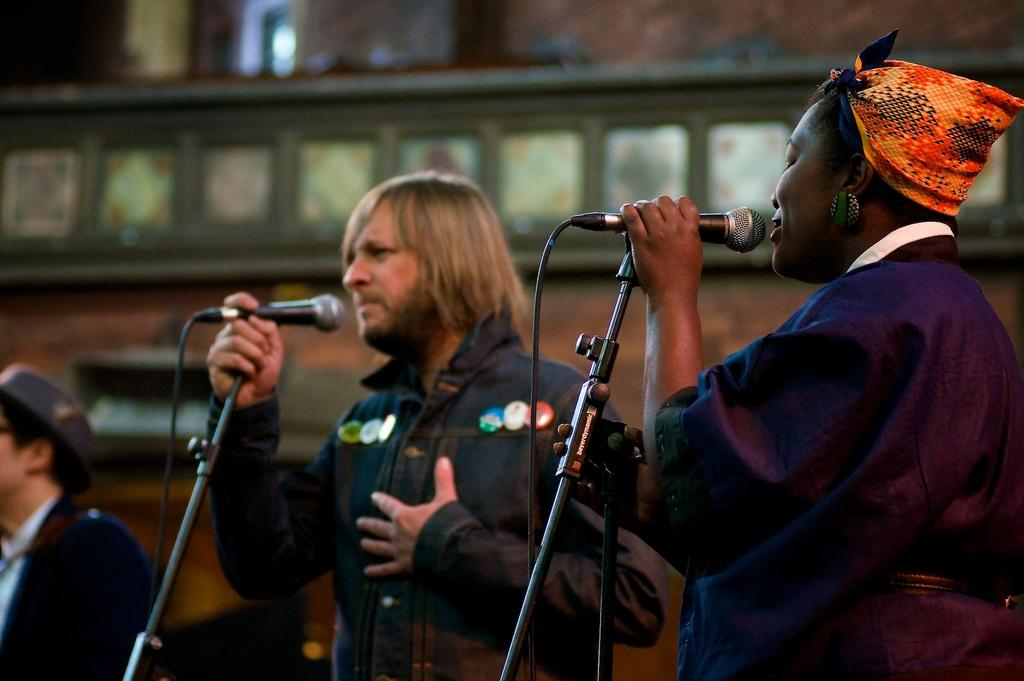What is the man in the image doing? The man is standing and singing in the image. What is the man holding in his hand? The man is holding a microphone in his hand. What is the woman in the image doing? The woman is also standing and singing in the image. How many people are present in the image? There is at least one person standing in the image. What type of pets are visible in the image? There are no pets present in the image. What kind of system is being used by the man and woman to share their ideas? There is no system or idea-sharing mentioned in the image; the man and woman are simply singing. 